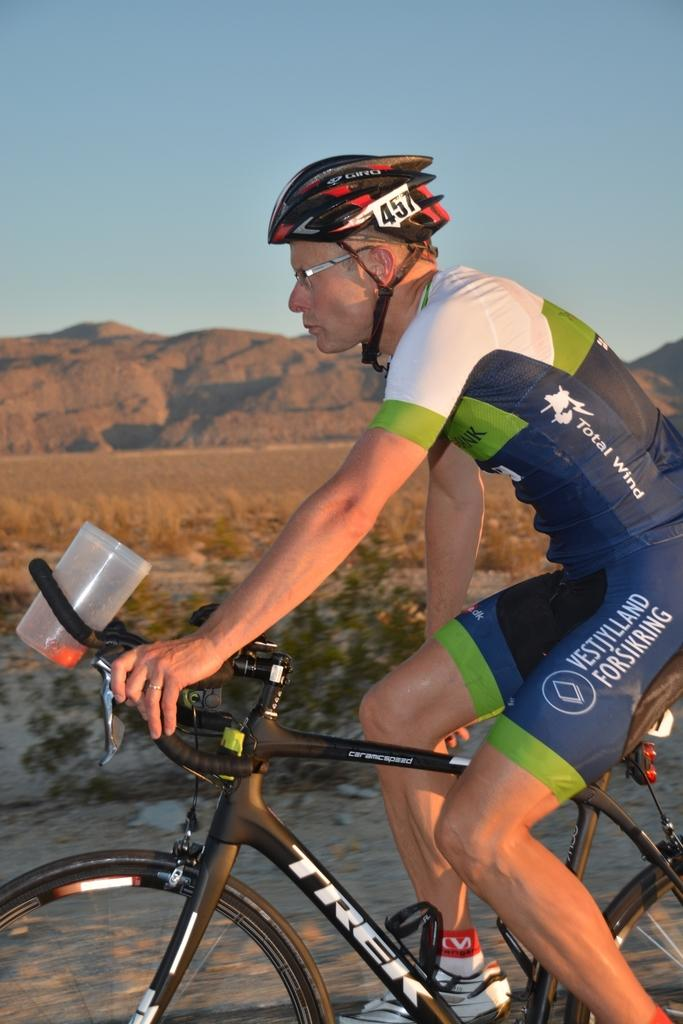What is the main subject of the image? There is a person riding a bicycle in the image. What safety precaution is the person taking while riding the bicycle? The person is wearing a helmet. What can be seen in the distance in the image? There are mountains in the background of the image. What type of vegetation is present in the image? Dry grass is present in the image. How many tickets are visible in the image? There are no tickets present in the image. What type of books can be seen in the image? There are no books present in the image. 